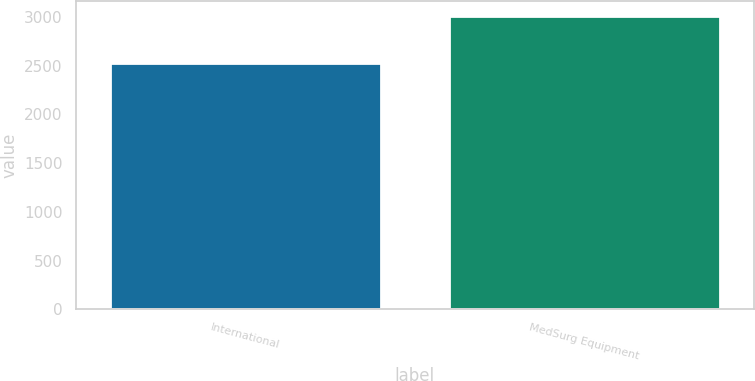Convert chart to OTSL. <chart><loc_0><loc_0><loc_500><loc_500><bar_chart><fcel>International<fcel>MedSurg Equipment<nl><fcel>2527.2<fcel>3011.6<nl></chart> 